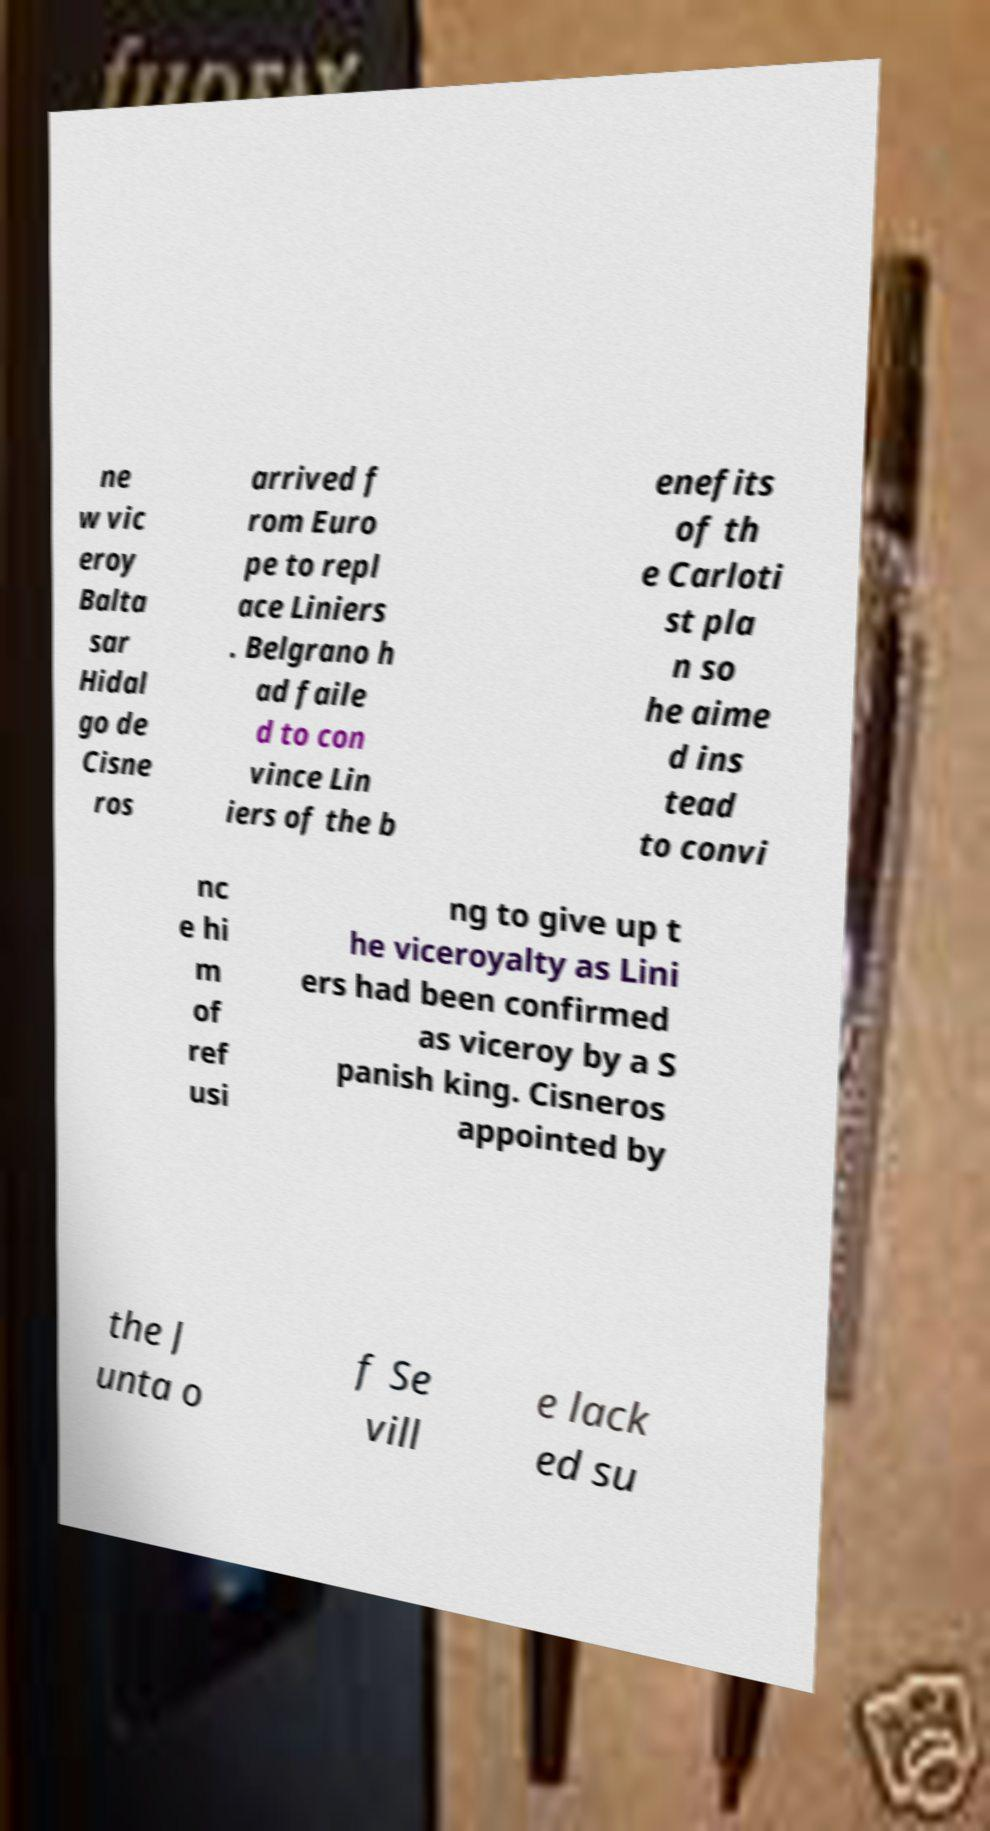For documentation purposes, I need the text within this image transcribed. Could you provide that? ne w vic eroy Balta sar Hidal go de Cisne ros arrived f rom Euro pe to repl ace Liniers . Belgrano h ad faile d to con vince Lin iers of the b enefits of th e Carloti st pla n so he aime d ins tead to convi nc e hi m of ref usi ng to give up t he viceroyalty as Lini ers had been confirmed as viceroy by a S panish king. Cisneros appointed by the J unta o f Se vill e lack ed su 